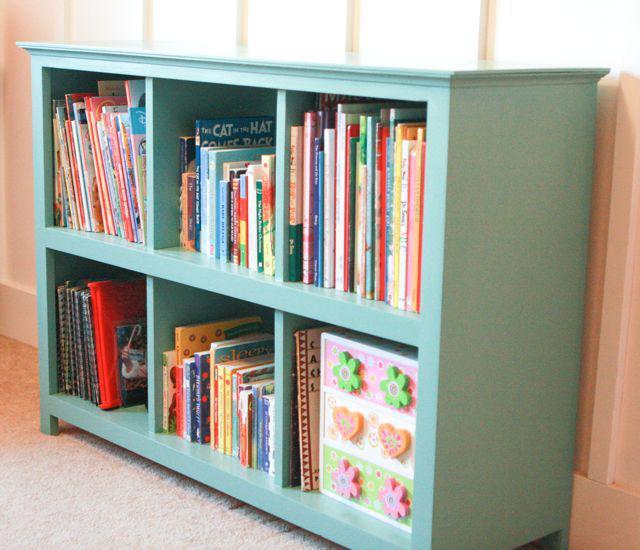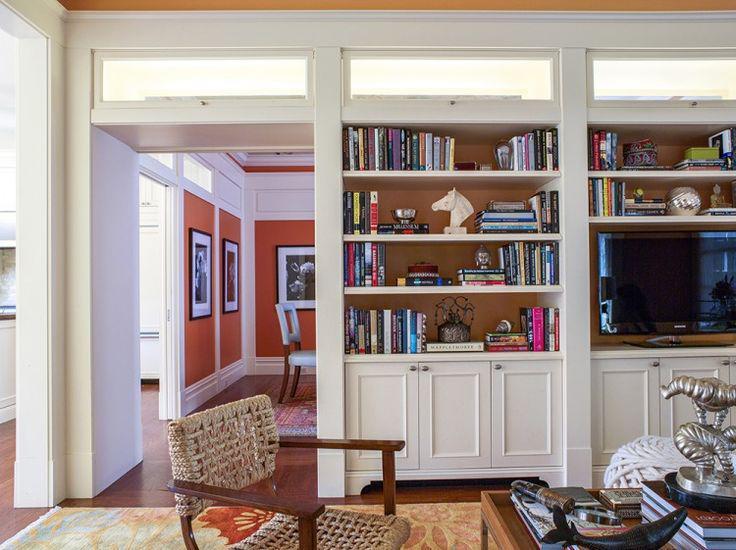The first image is the image on the left, the second image is the image on the right. Examine the images to the left and right. Is the description "The bookshelves in at least one image are flat boards with at least one open end, with items on the shelves serving as bookends." accurate? Answer yes or no. No. The first image is the image on the left, the second image is the image on the right. Examine the images to the left and right. Is the description "Left image shows traditional built-in white bookcase with a white back." accurate? Answer yes or no. No. 